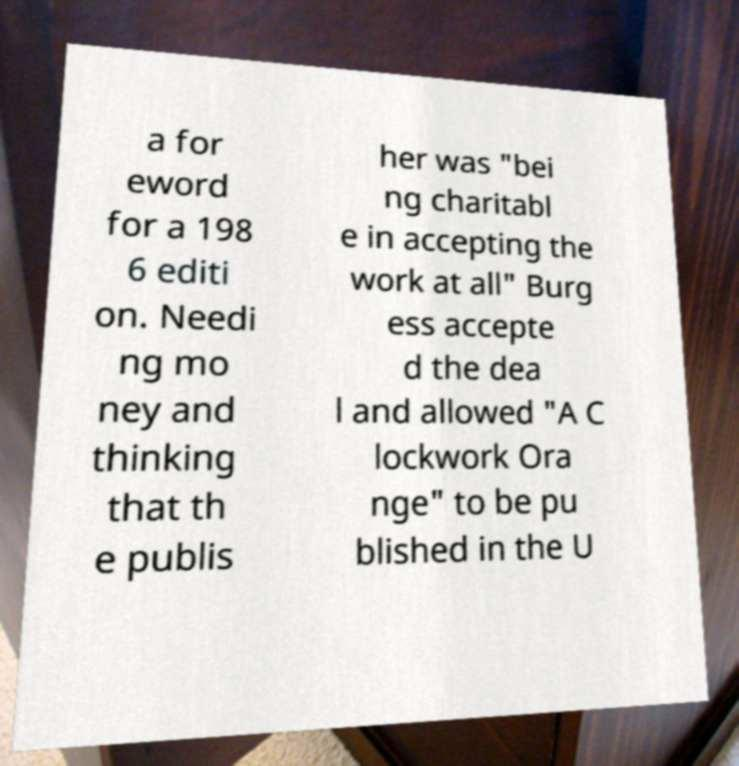For documentation purposes, I need the text within this image transcribed. Could you provide that? a for eword for a 198 6 editi on. Needi ng mo ney and thinking that th e publis her was "bei ng charitabl e in accepting the work at all" Burg ess accepte d the dea l and allowed "A C lockwork Ora nge" to be pu blished in the U 